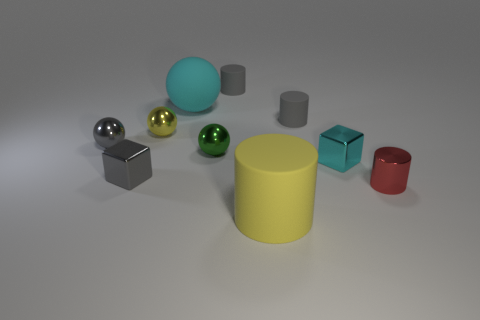Subtract all spheres. How many objects are left? 6 Add 3 red things. How many red things are left? 4 Add 3 red matte cylinders. How many red matte cylinders exist? 3 Subtract 1 gray balls. How many objects are left? 9 Subtract all small green shiny things. Subtract all brown shiny spheres. How many objects are left? 9 